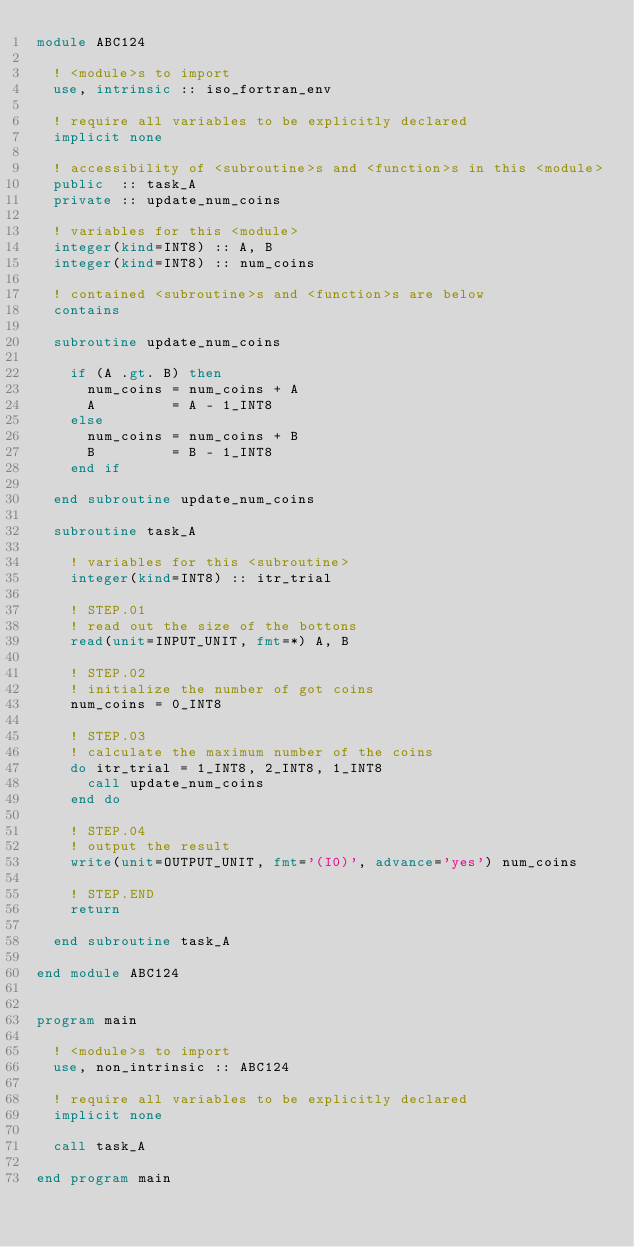Convert code to text. <code><loc_0><loc_0><loc_500><loc_500><_FORTRAN_>module ABC124

  ! <module>s to import
  use, intrinsic :: iso_fortran_env

  ! require all variables to be explicitly declared
  implicit none

  ! accessibility of <subroutine>s and <function>s in this <module>
  public  :: task_A
  private :: update_num_coins

  ! variables for this <module>
  integer(kind=INT8) :: A, B
  integer(kind=INT8) :: num_coins

  ! contained <subroutine>s and <function>s are below
  contains

  subroutine update_num_coins

    if (A .gt. B) then
      num_coins = num_coins + A
      A         = A - 1_INT8
    else
      num_coins = num_coins + B
      B         = B - 1_INT8
    end if

  end subroutine update_num_coins

  subroutine task_A

    ! variables for this <subroutine>
    integer(kind=INT8) :: itr_trial

    ! STEP.01
    ! read out the size of the bottons
    read(unit=INPUT_UNIT, fmt=*) A, B

    ! STEP.02
    ! initialize the number of got coins
    num_coins = 0_INT8

    ! STEP.03
    ! calculate the maximum number of the coins
    do itr_trial = 1_INT8, 2_INT8, 1_INT8
      call update_num_coins
    end do

    ! STEP.04
    ! output the result
    write(unit=OUTPUT_UNIT, fmt='(I0)', advance='yes') num_coins

    ! STEP.END
    return

  end subroutine task_A

end module ABC124


program main

  ! <module>s to import
  use, non_intrinsic :: ABC124

  ! require all variables to be explicitly declared
  implicit none

  call task_A

end program main</code> 